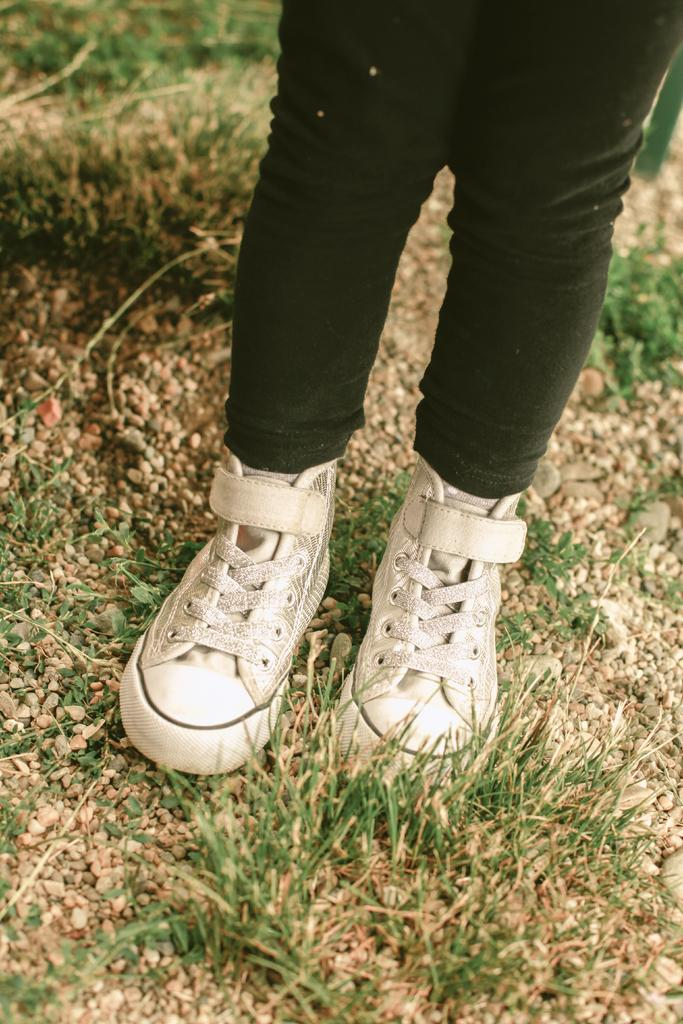Who or what is present in the image? There is a person in the image. What part of the person's body can be seen? The person's legs are visible. What type of footwear is the person wearing? The person is wearing shoes. What surface is the person standing on? The person is standing on the ground. What type of terrain is visible on the ground? Small stones and grass are present on the ground. What type of apparatus is the person using to fly in the image? There is no apparatus present in the image, and the person is not flying. How many boys are visible in the image? There is no mention of boys in the image, only a person. What type of bird can be seen perched on the person's shoulder in the image? There is no bird present in the image, let alone a crow. 